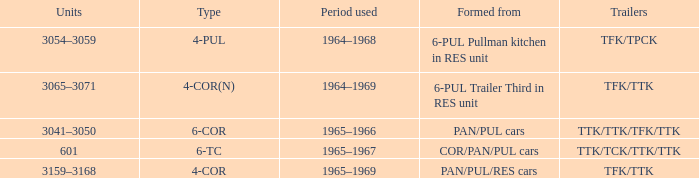Name the formed that has type of 4-cor PAN/PUL/RES cars. 